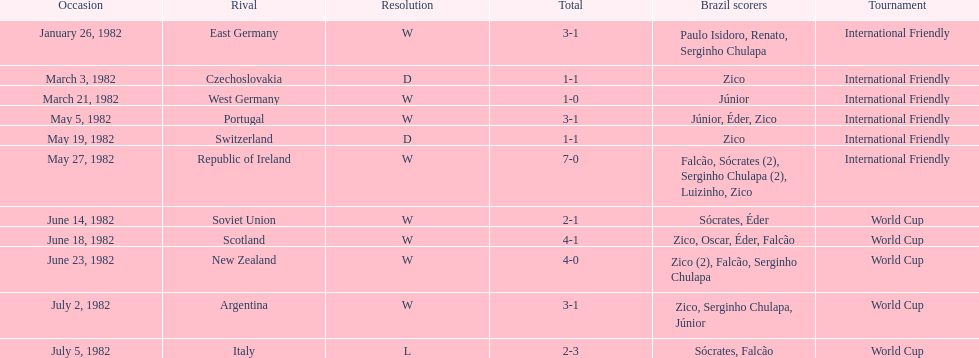During the 1982 season, what was the number of encounters between brazil and west germany? 1. 